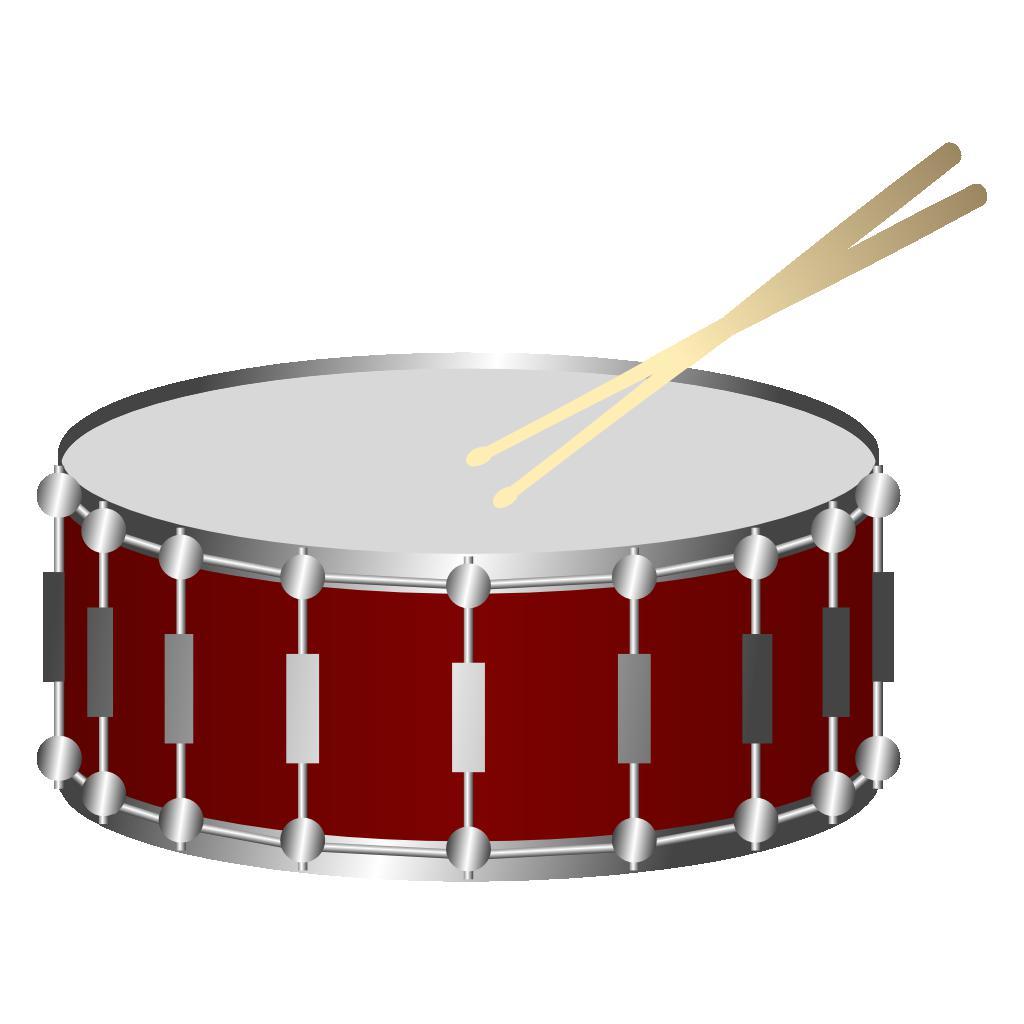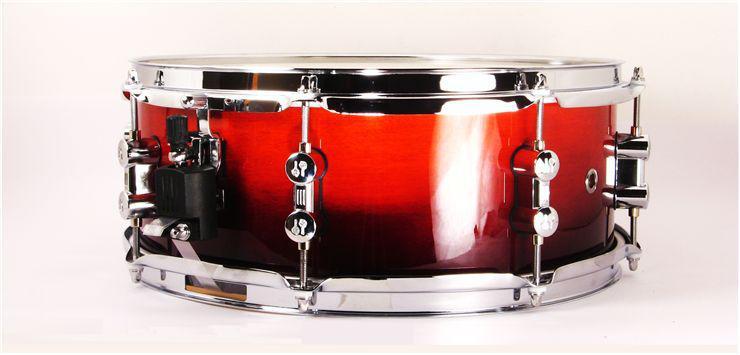The first image is the image on the left, the second image is the image on the right. Given the left and right images, does the statement "The drum on the left has a red exterior with rectangular silver shapes spaced around it, and the drum on the right is brown with round shapes spaced around it." hold true? Answer yes or no. No. 